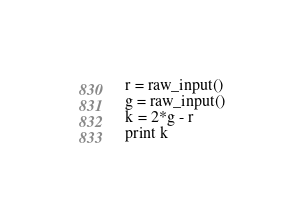Convert code to text. <code><loc_0><loc_0><loc_500><loc_500><_Python_>r = raw_input()
g = raw_input()
k = 2*g - r
print k</code> 